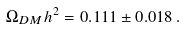<formula> <loc_0><loc_0><loc_500><loc_500>\Omega _ { D M } h ^ { 2 } = 0 . 1 1 1 \pm 0 . 0 1 8 \, .</formula> 